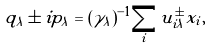<formula> <loc_0><loc_0><loc_500><loc_500>q _ { \lambda } \pm i p _ { \lambda } = ( \gamma _ { \lambda } ) ^ { - 1 } \sum _ { i } u ^ { \pm } _ { i \lambda } x _ { i } ,</formula> 